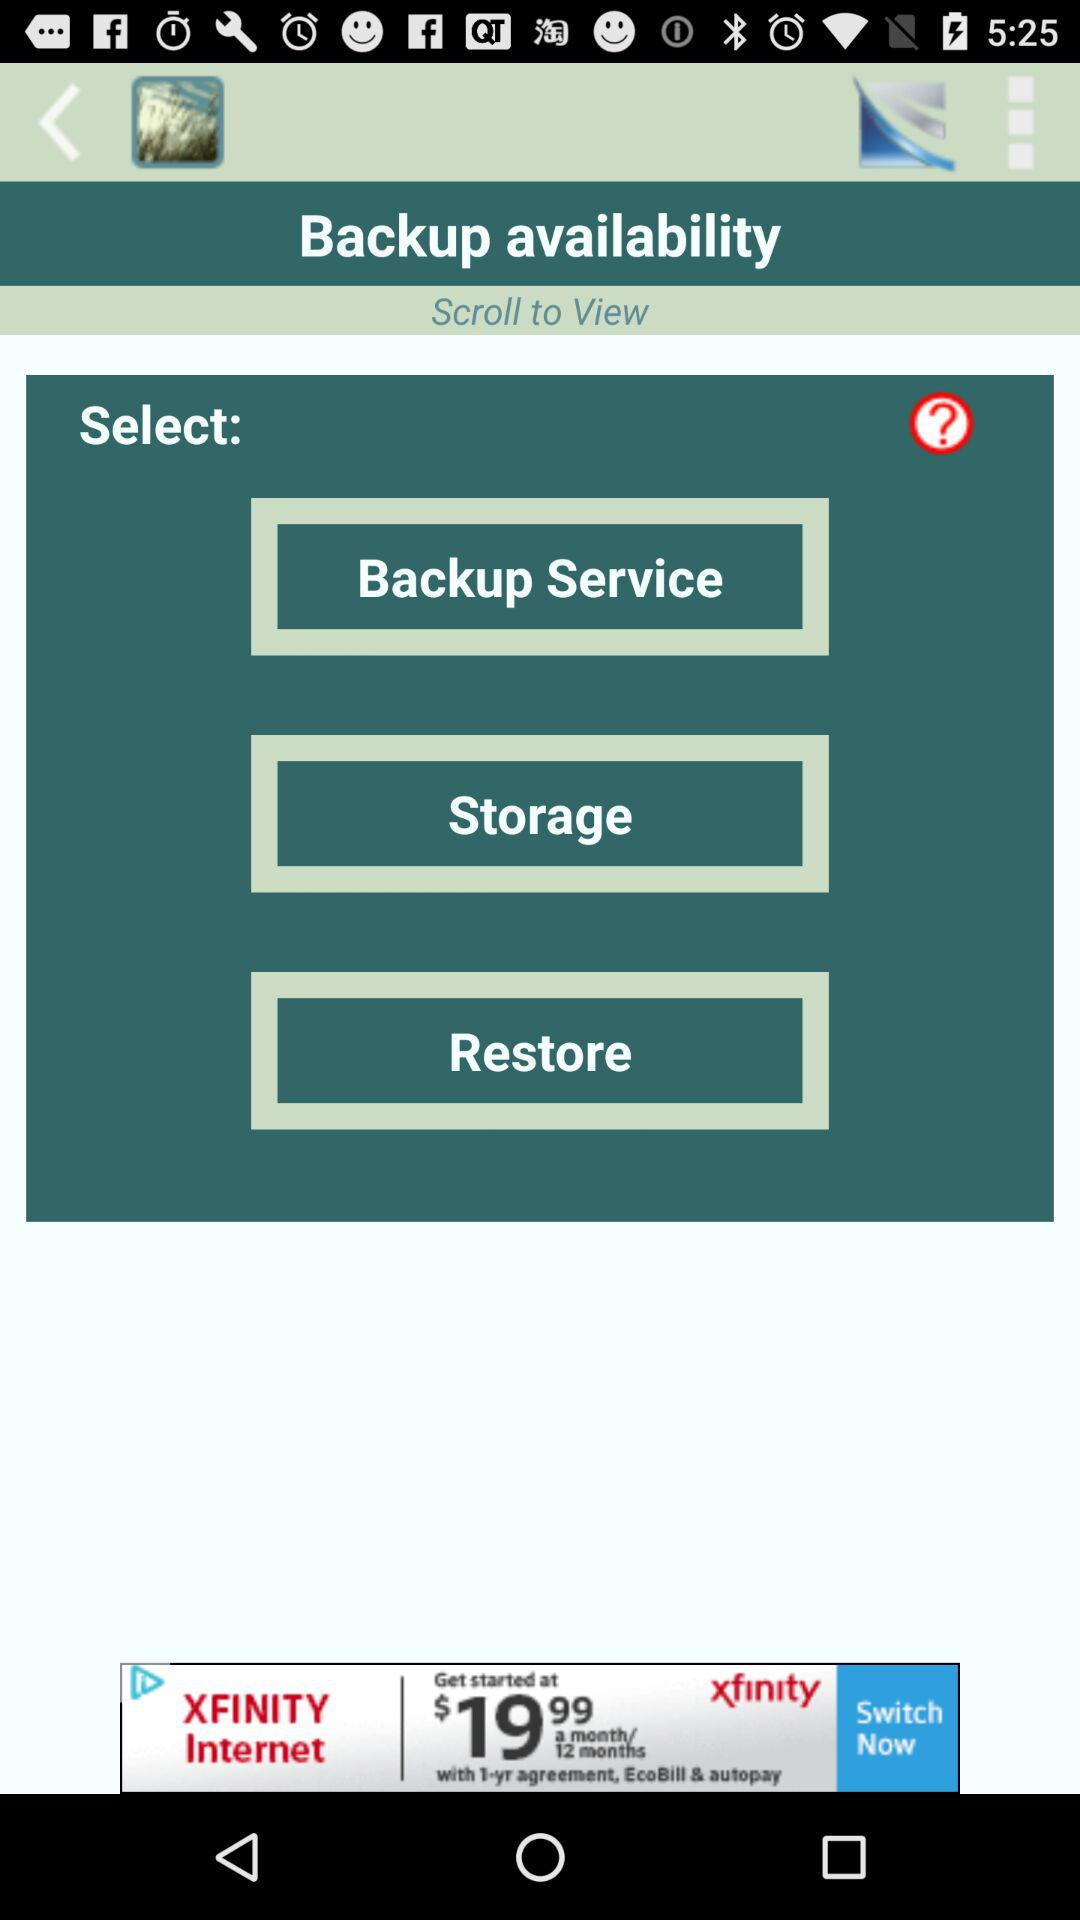Which options are given for selecting the backup availability? The options that are given for selecting the backup availability are "Backup Service", "Storage" and "Restore". 